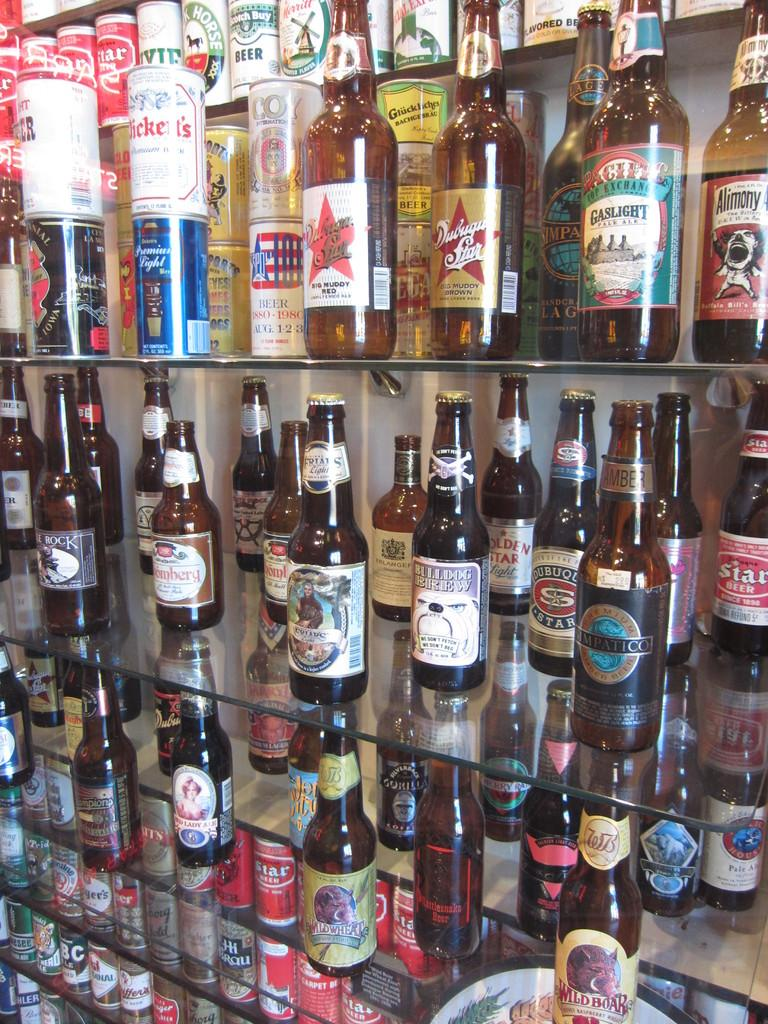What is the main subject of the image? The main subject of the image is many wine bottles. Where are the wine bottles located? The wine bottles are on a shelf. Can you see an airplane flying over the wine bottles in the image? No, there is no airplane visible in the image. What type of basket is holding the wine bottles in the image? There is no basket present in the image; the wine bottles are on a shelf. 